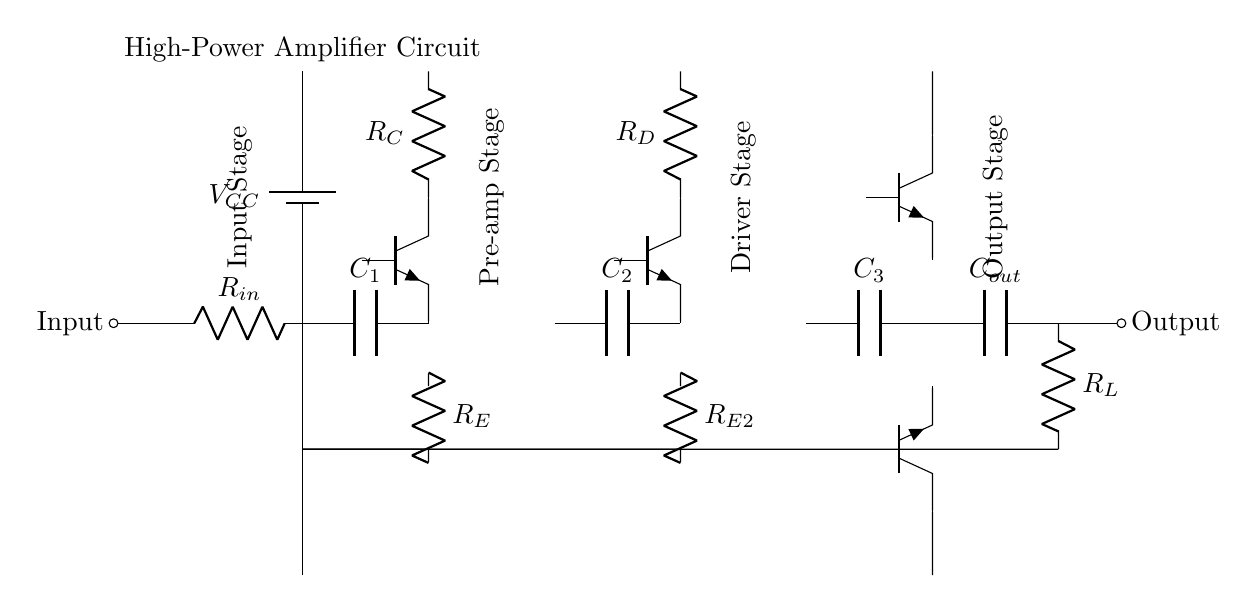What is the power supply voltage for this circuit? The circuit features a battery labeled as VCC, which indicates the power supply voltage. In most amplifiers, this is typically a higher voltage, often such as 12V or more, but the specific value is not provided within the diagram.
Answer: VCC What are the components in the input stage? The input stage consists of a resistor labeled R_in and a capacitor labeled C_1, as indicated by their symbols near the input connection. This configuration is typical for filtering or impedance matching in audio applications.
Answer: R_in, C_1 Which type of transistors are used in the pre-amp stage? The pre-amp stage includes a bipolar junction transistor (BJT) indicated by the label Tnpn for Q1, suggesting that it is an NPN transistor, commonly used for amplification.
Answer: NPN What is the purpose of the output capacitor? The output capacitor labeled C_out serves to block direct current while allowing alternating current signals to pass, which is important to prevent any DC offset from reaching the speakers.
Answer: AC coupling How many stages are there in the amplifier circuit? The circuit diagram displays four distinct stages: Input Stage, Pre-amp Stage, Driver Stage, and Output Stage, each performing a specific function in amplifying the audio signal through different levels of amplification.
Answer: Four What type of load is connected at the output? The output connects to a load labeled R_L, which typically represents the resistance of speakers in audio applications, confirming this is designed for driving sound systems.
Answer: R_L How is feedback applied in this circuit? The circuit does not explicitly show feedback paths, but typically feedback would be integrated in amplifiers to stabilize gain through connections from the output back to earlier stages, primarily through resistors. However, this implementation lacks a clear feedback network depicted here.
Answer: Not shown 